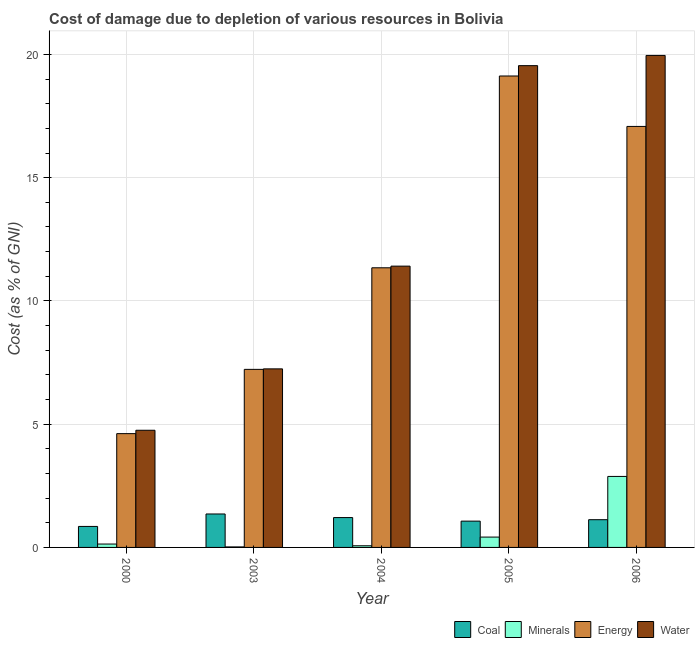How many different coloured bars are there?
Your response must be concise. 4. How many groups of bars are there?
Offer a terse response. 5. Are the number of bars on each tick of the X-axis equal?
Provide a succinct answer. Yes. How many bars are there on the 3rd tick from the left?
Provide a short and direct response. 4. What is the cost of damage due to depletion of minerals in 2004?
Provide a short and direct response. 0.07. Across all years, what is the maximum cost of damage due to depletion of energy?
Your response must be concise. 19.13. Across all years, what is the minimum cost of damage due to depletion of coal?
Ensure brevity in your answer.  0.85. What is the total cost of damage due to depletion of minerals in the graph?
Offer a terse response. 3.52. What is the difference between the cost of damage due to depletion of energy in 2004 and that in 2005?
Keep it short and to the point. -7.78. What is the difference between the cost of damage due to depletion of coal in 2006 and the cost of damage due to depletion of water in 2000?
Make the answer very short. 0.27. What is the average cost of damage due to depletion of water per year?
Offer a very short reply. 12.58. In the year 2005, what is the difference between the cost of damage due to depletion of energy and cost of damage due to depletion of coal?
Your response must be concise. 0. What is the ratio of the cost of damage due to depletion of energy in 2000 to that in 2004?
Your response must be concise. 0.41. What is the difference between the highest and the second highest cost of damage due to depletion of water?
Your answer should be very brief. 0.42. What is the difference between the highest and the lowest cost of damage due to depletion of minerals?
Provide a succinct answer. 2.86. In how many years, is the cost of damage due to depletion of energy greater than the average cost of damage due to depletion of energy taken over all years?
Offer a terse response. 2. What does the 4th bar from the left in 2004 represents?
Give a very brief answer. Water. What does the 4th bar from the right in 2006 represents?
Provide a succinct answer. Coal. Are all the bars in the graph horizontal?
Your response must be concise. No. How many years are there in the graph?
Ensure brevity in your answer.  5. Does the graph contain any zero values?
Offer a terse response. No. How are the legend labels stacked?
Ensure brevity in your answer.  Horizontal. What is the title of the graph?
Offer a very short reply. Cost of damage due to depletion of various resources in Bolivia . What is the label or title of the X-axis?
Your response must be concise. Year. What is the label or title of the Y-axis?
Offer a very short reply. Cost (as % of GNI). What is the Cost (as % of GNI) in Coal in 2000?
Your response must be concise. 0.85. What is the Cost (as % of GNI) in Minerals in 2000?
Ensure brevity in your answer.  0.14. What is the Cost (as % of GNI) of Energy in 2000?
Keep it short and to the point. 4.62. What is the Cost (as % of GNI) of Water in 2000?
Provide a short and direct response. 4.75. What is the Cost (as % of GNI) of Coal in 2003?
Ensure brevity in your answer.  1.36. What is the Cost (as % of GNI) in Minerals in 2003?
Your answer should be very brief. 0.02. What is the Cost (as % of GNI) of Energy in 2003?
Offer a terse response. 7.22. What is the Cost (as % of GNI) of Water in 2003?
Keep it short and to the point. 7.24. What is the Cost (as % of GNI) in Coal in 2004?
Provide a short and direct response. 1.21. What is the Cost (as % of GNI) of Minerals in 2004?
Give a very brief answer. 0.07. What is the Cost (as % of GNI) of Energy in 2004?
Your response must be concise. 11.34. What is the Cost (as % of GNI) of Water in 2004?
Your response must be concise. 11.41. What is the Cost (as % of GNI) of Coal in 2005?
Ensure brevity in your answer.  1.07. What is the Cost (as % of GNI) of Minerals in 2005?
Provide a short and direct response. 0.42. What is the Cost (as % of GNI) in Energy in 2005?
Provide a succinct answer. 19.13. What is the Cost (as % of GNI) in Water in 2005?
Offer a very short reply. 19.54. What is the Cost (as % of GNI) of Coal in 2006?
Your response must be concise. 1.12. What is the Cost (as % of GNI) in Minerals in 2006?
Offer a terse response. 2.88. What is the Cost (as % of GNI) of Energy in 2006?
Your answer should be compact. 17.08. What is the Cost (as % of GNI) in Water in 2006?
Keep it short and to the point. 19.96. Across all years, what is the maximum Cost (as % of GNI) of Coal?
Offer a very short reply. 1.36. Across all years, what is the maximum Cost (as % of GNI) in Minerals?
Your response must be concise. 2.88. Across all years, what is the maximum Cost (as % of GNI) in Energy?
Make the answer very short. 19.13. Across all years, what is the maximum Cost (as % of GNI) of Water?
Provide a short and direct response. 19.96. Across all years, what is the minimum Cost (as % of GNI) of Coal?
Give a very brief answer. 0.85. Across all years, what is the minimum Cost (as % of GNI) in Minerals?
Keep it short and to the point. 0.02. Across all years, what is the minimum Cost (as % of GNI) in Energy?
Your response must be concise. 4.62. Across all years, what is the minimum Cost (as % of GNI) of Water?
Offer a very short reply. 4.75. What is the total Cost (as % of GNI) of Coal in the graph?
Provide a succinct answer. 5.61. What is the total Cost (as % of GNI) in Minerals in the graph?
Make the answer very short. 3.52. What is the total Cost (as % of GNI) in Energy in the graph?
Your answer should be very brief. 59.39. What is the total Cost (as % of GNI) in Water in the graph?
Provide a succinct answer. 62.91. What is the difference between the Cost (as % of GNI) in Coal in 2000 and that in 2003?
Your answer should be compact. -0.5. What is the difference between the Cost (as % of GNI) of Minerals in 2000 and that in 2003?
Your answer should be compact. 0.12. What is the difference between the Cost (as % of GNI) in Energy in 2000 and that in 2003?
Provide a succinct answer. -2.61. What is the difference between the Cost (as % of GNI) in Water in 2000 and that in 2003?
Offer a terse response. -2.49. What is the difference between the Cost (as % of GNI) of Coal in 2000 and that in 2004?
Keep it short and to the point. -0.36. What is the difference between the Cost (as % of GNI) of Minerals in 2000 and that in 2004?
Offer a very short reply. 0.07. What is the difference between the Cost (as % of GNI) in Energy in 2000 and that in 2004?
Make the answer very short. -6.73. What is the difference between the Cost (as % of GNI) of Water in 2000 and that in 2004?
Your response must be concise. -6.66. What is the difference between the Cost (as % of GNI) of Coal in 2000 and that in 2005?
Offer a very short reply. -0.21. What is the difference between the Cost (as % of GNI) of Minerals in 2000 and that in 2005?
Your answer should be compact. -0.28. What is the difference between the Cost (as % of GNI) of Energy in 2000 and that in 2005?
Make the answer very short. -14.51. What is the difference between the Cost (as % of GNI) of Water in 2000 and that in 2005?
Your response must be concise. -14.79. What is the difference between the Cost (as % of GNI) in Coal in 2000 and that in 2006?
Keep it short and to the point. -0.27. What is the difference between the Cost (as % of GNI) of Minerals in 2000 and that in 2006?
Provide a short and direct response. -2.74. What is the difference between the Cost (as % of GNI) in Energy in 2000 and that in 2006?
Give a very brief answer. -12.46. What is the difference between the Cost (as % of GNI) in Water in 2000 and that in 2006?
Provide a succinct answer. -15.21. What is the difference between the Cost (as % of GNI) of Coal in 2003 and that in 2004?
Your answer should be compact. 0.15. What is the difference between the Cost (as % of GNI) in Minerals in 2003 and that in 2004?
Give a very brief answer. -0.05. What is the difference between the Cost (as % of GNI) of Energy in 2003 and that in 2004?
Your response must be concise. -4.12. What is the difference between the Cost (as % of GNI) of Water in 2003 and that in 2004?
Ensure brevity in your answer.  -4.17. What is the difference between the Cost (as % of GNI) in Coal in 2003 and that in 2005?
Your response must be concise. 0.29. What is the difference between the Cost (as % of GNI) of Minerals in 2003 and that in 2005?
Your answer should be compact. -0.4. What is the difference between the Cost (as % of GNI) of Energy in 2003 and that in 2005?
Provide a short and direct response. -11.9. What is the difference between the Cost (as % of GNI) of Water in 2003 and that in 2005?
Your answer should be compact. -12.3. What is the difference between the Cost (as % of GNI) in Coal in 2003 and that in 2006?
Offer a very short reply. 0.23. What is the difference between the Cost (as % of GNI) of Minerals in 2003 and that in 2006?
Make the answer very short. -2.86. What is the difference between the Cost (as % of GNI) of Energy in 2003 and that in 2006?
Provide a succinct answer. -9.86. What is the difference between the Cost (as % of GNI) of Water in 2003 and that in 2006?
Provide a short and direct response. -12.72. What is the difference between the Cost (as % of GNI) of Coal in 2004 and that in 2005?
Provide a short and direct response. 0.14. What is the difference between the Cost (as % of GNI) of Minerals in 2004 and that in 2005?
Offer a very short reply. -0.35. What is the difference between the Cost (as % of GNI) of Energy in 2004 and that in 2005?
Keep it short and to the point. -7.78. What is the difference between the Cost (as % of GNI) in Water in 2004 and that in 2005?
Offer a very short reply. -8.13. What is the difference between the Cost (as % of GNI) of Coal in 2004 and that in 2006?
Your response must be concise. 0.09. What is the difference between the Cost (as % of GNI) in Minerals in 2004 and that in 2006?
Make the answer very short. -2.81. What is the difference between the Cost (as % of GNI) in Energy in 2004 and that in 2006?
Your response must be concise. -5.73. What is the difference between the Cost (as % of GNI) of Water in 2004 and that in 2006?
Your response must be concise. -8.55. What is the difference between the Cost (as % of GNI) of Coal in 2005 and that in 2006?
Provide a succinct answer. -0.06. What is the difference between the Cost (as % of GNI) in Minerals in 2005 and that in 2006?
Provide a succinct answer. -2.46. What is the difference between the Cost (as % of GNI) of Energy in 2005 and that in 2006?
Offer a terse response. 2.05. What is the difference between the Cost (as % of GNI) of Water in 2005 and that in 2006?
Keep it short and to the point. -0.41. What is the difference between the Cost (as % of GNI) in Coal in 2000 and the Cost (as % of GNI) in Minerals in 2003?
Ensure brevity in your answer.  0.83. What is the difference between the Cost (as % of GNI) in Coal in 2000 and the Cost (as % of GNI) in Energy in 2003?
Provide a short and direct response. -6.37. What is the difference between the Cost (as % of GNI) in Coal in 2000 and the Cost (as % of GNI) in Water in 2003?
Your answer should be compact. -6.39. What is the difference between the Cost (as % of GNI) in Minerals in 2000 and the Cost (as % of GNI) in Energy in 2003?
Offer a very short reply. -7.09. What is the difference between the Cost (as % of GNI) of Minerals in 2000 and the Cost (as % of GNI) of Water in 2003?
Provide a succinct answer. -7.11. What is the difference between the Cost (as % of GNI) of Energy in 2000 and the Cost (as % of GNI) of Water in 2003?
Provide a succinct answer. -2.63. What is the difference between the Cost (as % of GNI) of Coal in 2000 and the Cost (as % of GNI) of Minerals in 2004?
Your response must be concise. 0.78. What is the difference between the Cost (as % of GNI) in Coal in 2000 and the Cost (as % of GNI) in Energy in 2004?
Your response must be concise. -10.49. What is the difference between the Cost (as % of GNI) of Coal in 2000 and the Cost (as % of GNI) of Water in 2004?
Keep it short and to the point. -10.56. What is the difference between the Cost (as % of GNI) in Minerals in 2000 and the Cost (as % of GNI) in Energy in 2004?
Keep it short and to the point. -11.21. What is the difference between the Cost (as % of GNI) in Minerals in 2000 and the Cost (as % of GNI) in Water in 2004?
Keep it short and to the point. -11.27. What is the difference between the Cost (as % of GNI) in Energy in 2000 and the Cost (as % of GNI) in Water in 2004?
Your answer should be very brief. -6.8. What is the difference between the Cost (as % of GNI) of Coal in 2000 and the Cost (as % of GNI) of Minerals in 2005?
Provide a succinct answer. 0.43. What is the difference between the Cost (as % of GNI) of Coal in 2000 and the Cost (as % of GNI) of Energy in 2005?
Offer a very short reply. -18.27. What is the difference between the Cost (as % of GNI) of Coal in 2000 and the Cost (as % of GNI) of Water in 2005?
Make the answer very short. -18.69. What is the difference between the Cost (as % of GNI) of Minerals in 2000 and the Cost (as % of GNI) of Energy in 2005?
Your answer should be very brief. -18.99. What is the difference between the Cost (as % of GNI) in Minerals in 2000 and the Cost (as % of GNI) in Water in 2005?
Your answer should be compact. -19.41. What is the difference between the Cost (as % of GNI) in Energy in 2000 and the Cost (as % of GNI) in Water in 2005?
Your answer should be very brief. -14.93. What is the difference between the Cost (as % of GNI) of Coal in 2000 and the Cost (as % of GNI) of Minerals in 2006?
Make the answer very short. -2.03. What is the difference between the Cost (as % of GNI) of Coal in 2000 and the Cost (as % of GNI) of Energy in 2006?
Offer a terse response. -16.23. What is the difference between the Cost (as % of GNI) in Coal in 2000 and the Cost (as % of GNI) in Water in 2006?
Offer a very short reply. -19.11. What is the difference between the Cost (as % of GNI) of Minerals in 2000 and the Cost (as % of GNI) of Energy in 2006?
Your answer should be very brief. -16.94. What is the difference between the Cost (as % of GNI) of Minerals in 2000 and the Cost (as % of GNI) of Water in 2006?
Ensure brevity in your answer.  -19.82. What is the difference between the Cost (as % of GNI) of Energy in 2000 and the Cost (as % of GNI) of Water in 2006?
Make the answer very short. -15.34. What is the difference between the Cost (as % of GNI) in Coal in 2003 and the Cost (as % of GNI) in Minerals in 2004?
Your response must be concise. 1.29. What is the difference between the Cost (as % of GNI) of Coal in 2003 and the Cost (as % of GNI) of Energy in 2004?
Your answer should be compact. -9.99. What is the difference between the Cost (as % of GNI) in Coal in 2003 and the Cost (as % of GNI) in Water in 2004?
Give a very brief answer. -10.05. What is the difference between the Cost (as % of GNI) in Minerals in 2003 and the Cost (as % of GNI) in Energy in 2004?
Offer a terse response. -11.32. What is the difference between the Cost (as % of GNI) of Minerals in 2003 and the Cost (as % of GNI) of Water in 2004?
Ensure brevity in your answer.  -11.39. What is the difference between the Cost (as % of GNI) of Energy in 2003 and the Cost (as % of GNI) of Water in 2004?
Provide a succinct answer. -4.19. What is the difference between the Cost (as % of GNI) in Coal in 2003 and the Cost (as % of GNI) in Minerals in 2005?
Provide a short and direct response. 0.94. What is the difference between the Cost (as % of GNI) of Coal in 2003 and the Cost (as % of GNI) of Energy in 2005?
Provide a short and direct response. -17.77. What is the difference between the Cost (as % of GNI) of Coal in 2003 and the Cost (as % of GNI) of Water in 2005?
Offer a terse response. -18.19. What is the difference between the Cost (as % of GNI) of Minerals in 2003 and the Cost (as % of GNI) of Energy in 2005?
Offer a very short reply. -19.1. What is the difference between the Cost (as % of GNI) of Minerals in 2003 and the Cost (as % of GNI) of Water in 2005?
Offer a very short reply. -19.52. What is the difference between the Cost (as % of GNI) in Energy in 2003 and the Cost (as % of GNI) in Water in 2005?
Ensure brevity in your answer.  -12.32. What is the difference between the Cost (as % of GNI) of Coal in 2003 and the Cost (as % of GNI) of Minerals in 2006?
Your response must be concise. -1.52. What is the difference between the Cost (as % of GNI) in Coal in 2003 and the Cost (as % of GNI) in Energy in 2006?
Your answer should be compact. -15.72. What is the difference between the Cost (as % of GNI) in Coal in 2003 and the Cost (as % of GNI) in Water in 2006?
Offer a terse response. -18.6. What is the difference between the Cost (as % of GNI) in Minerals in 2003 and the Cost (as % of GNI) in Energy in 2006?
Offer a very short reply. -17.06. What is the difference between the Cost (as % of GNI) of Minerals in 2003 and the Cost (as % of GNI) of Water in 2006?
Your answer should be compact. -19.94. What is the difference between the Cost (as % of GNI) in Energy in 2003 and the Cost (as % of GNI) in Water in 2006?
Keep it short and to the point. -12.74. What is the difference between the Cost (as % of GNI) in Coal in 2004 and the Cost (as % of GNI) in Minerals in 2005?
Give a very brief answer. 0.79. What is the difference between the Cost (as % of GNI) in Coal in 2004 and the Cost (as % of GNI) in Energy in 2005?
Provide a succinct answer. -17.91. What is the difference between the Cost (as % of GNI) in Coal in 2004 and the Cost (as % of GNI) in Water in 2005?
Provide a short and direct response. -18.33. What is the difference between the Cost (as % of GNI) in Minerals in 2004 and the Cost (as % of GNI) in Energy in 2005?
Your answer should be very brief. -19.06. What is the difference between the Cost (as % of GNI) of Minerals in 2004 and the Cost (as % of GNI) of Water in 2005?
Give a very brief answer. -19.48. What is the difference between the Cost (as % of GNI) in Energy in 2004 and the Cost (as % of GNI) in Water in 2005?
Provide a succinct answer. -8.2. What is the difference between the Cost (as % of GNI) in Coal in 2004 and the Cost (as % of GNI) in Minerals in 2006?
Your answer should be compact. -1.67. What is the difference between the Cost (as % of GNI) of Coal in 2004 and the Cost (as % of GNI) of Energy in 2006?
Provide a short and direct response. -15.87. What is the difference between the Cost (as % of GNI) in Coal in 2004 and the Cost (as % of GNI) in Water in 2006?
Make the answer very short. -18.75. What is the difference between the Cost (as % of GNI) of Minerals in 2004 and the Cost (as % of GNI) of Energy in 2006?
Provide a short and direct response. -17.01. What is the difference between the Cost (as % of GNI) in Minerals in 2004 and the Cost (as % of GNI) in Water in 2006?
Your answer should be compact. -19.89. What is the difference between the Cost (as % of GNI) of Energy in 2004 and the Cost (as % of GNI) of Water in 2006?
Your answer should be compact. -8.62. What is the difference between the Cost (as % of GNI) of Coal in 2005 and the Cost (as % of GNI) of Minerals in 2006?
Give a very brief answer. -1.81. What is the difference between the Cost (as % of GNI) in Coal in 2005 and the Cost (as % of GNI) in Energy in 2006?
Provide a succinct answer. -16.01. What is the difference between the Cost (as % of GNI) in Coal in 2005 and the Cost (as % of GNI) in Water in 2006?
Keep it short and to the point. -18.89. What is the difference between the Cost (as % of GNI) of Minerals in 2005 and the Cost (as % of GNI) of Energy in 2006?
Provide a short and direct response. -16.66. What is the difference between the Cost (as % of GNI) in Minerals in 2005 and the Cost (as % of GNI) in Water in 2006?
Give a very brief answer. -19.54. What is the difference between the Cost (as % of GNI) of Energy in 2005 and the Cost (as % of GNI) of Water in 2006?
Offer a very short reply. -0.83. What is the average Cost (as % of GNI) of Coal per year?
Offer a very short reply. 1.12. What is the average Cost (as % of GNI) of Minerals per year?
Ensure brevity in your answer.  0.7. What is the average Cost (as % of GNI) of Energy per year?
Your answer should be very brief. 11.88. What is the average Cost (as % of GNI) of Water per year?
Your answer should be compact. 12.58. In the year 2000, what is the difference between the Cost (as % of GNI) of Coal and Cost (as % of GNI) of Minerals?
Give a very brief answer. 0.71. In the year 2000, what is the difference between the Cost (as % of GNI) of Coal and Cost (as % of GNI) of Energy?
Keep it short and to the point. -3.76. In the year 2000, what is the difference between the Cost (as % of GNI) of Coal and Cost (as % of GNI) of Water?
Give a very brief answer. -3.9. In the year 2000, what is the difference between the Cost (as % of GNI) of Minerals and Cost (as % of GNI) of Energy?
Provide a succinct answer. -4.48. In the year 2000, what is the difference between the Cost (as % of GNI) of Minerals and Cost (as % of GNI) of Water?
Your answer should be very brief. -4.62. In the year 2000, what is the difference between the Cost (as % of GNI) in Energy and Cost (as % of GNI) in Water?
Make the answer very short. -0.14. In the year 2003, what is the difference between the Cost (as % of GNI) of Coal and Cost (as % of GNI) of Minerals?
Make the answer very short. 1.34. In the year 2003, what is the difference between the Cost (as % of GNI) in Coal and Cost (as % of GNI) in Energy?
Make the answer very short. -5.87. In the year 2003, what is the difference between the Cost (as % of GNI) in Coal and Cost (as % of GNI) in Water?
Provide a short and direct response. -5.89. In the year 2003, what is the difference between the Cost (as % of GNI) of Minerals and Cost (as % of GNI) of Energy?
Your response must be concise. -7.2. In the year 2003, what is the difference between the Cost (as % of GNI) in Minerals and Cost (as % of GNI) in Water?
Your response must be concise. -7.22. In the year 2003, what is the difference between the Cost (as % of GNI) of Energy and Cost (as % of GNI) of Water?
Ensure brevity in your answer.  -0.02. In the year 2004, what is the difference between the Cost (as % of GNI) in Coal and Cost (as % of GNI) in Minerals?
Provide a succinct answer. 1.14. In the year 2004, what is the difference between the Cost (as % of GNI) in Coal and Cost (as % of GNI) in Energy?
Provide a short and direct response. -10.13. In the year 2004, what is the difference between the Cost (as % of GNI) of Coal and Cost (as % of GNI) of Water?
Provide a succinct answer. -10.2. In the year 2004, what is the difference between the Cost (as % of GNI) of Minerals and Cost (as % of GNI) of Energy?
Ensure brevity in your answer.  -11.28. In the year 2004, what is the difference between the Cost (as % of GNI) of Minerals and Cost (as % of GNI) of Water?
Your answer should be very brief. -11.34. In the year 2004, what is the difference between the Cost (as % of GNI) of Energy and Cost (as % of GNI) of Water?
Offer a very short reply. -0.07. In the year 2005, what is the difference between the Cost (as % of GNI) of Coal and Cost (as % of GNI) of Minerals?
Offer a very short reply. 0.65. In the year 2005, what is the difference between the Cost (as % of GNI) of Coal and Cost (as % of GNI) of Energy?
Your response must be concise. -18.06. In the year 2005, what is the difference between the Cost (as % of GNI) in Coal and Cost (as % of GNI) in Water?
Give a very brief answer. -18.48. In the year 2005, what is the difference between the Cost (as % of GNI) of Minerals and Cost (as % of GNI) of Energy?
Offer a very short reply. -18.71. In the year 2005, what is the difference between the Cost (as % of GNI) in Minerals and Cost (as % of GNI) in Water?
Offer a terse response. -19.13. In the year 2005, what is the difference between the Cost (as % of GNI) of Energy and Cost (as % of GNI) of Water?
Provide a succinct answer. -0.42. In the year 2006, what is the difference between the Cost (as % of GNI) in Coal and Cost (as % of GNI) in Minerals?
Your answer should be very brief. -1.76. In the year 2006, what is the difference between the Cost (as % of GNI) of Coal and Cost (as % of GNI) of Energy?
Offer a very short reply. -15.95. In the year 2006, what is the difference between the Cost (as % of GNI) of Coal and Cost (as % of GNI) of Water?
Provide a short and direct response. -18.83. In the year 2006, what is the difference between the Cost (as % of GNI) in Minerals and Cost (as % of GNI) in Energy?
Offer a terse response. -14.2. In the year 2006, what is the difference between the Cost (as % of GNI) in Minerals and Cost (as % of GNI) in Water?
Give a very brief answer. -17.08. In the year 2006, what is the difference between the Cost (as % of GNI) of Energy and Cost (as % of GNI) of Water?
Keep it short and to the point. -2.88. What is the ratio of the Cost (as % of GNI) of Coal in 2000 to that in 2003?
Ensure brevity in your answer.  0.63. What is the ratio of the Cost (as % of GNI) in Minerals in 2000 to that in 2003?
Your response must be concise. 6.68. What is the ratio of the Cost (as % of GNI) of Energy in 2000 to that in 2003?
Offer a very short reply. 0.64. What is the ratio of the Cost (as % of GNI) of Water in 2000 to that in 2003?
Make the answer very short. 0.66. What is the ratio of the Cost (as % of GNI) of Coal in 2000 to that in 2004?
Give a very brief answer. 0.7. What is the ratio of the Cost (as % of GNI) of Minerals in 2000 to that in 2004?
Keep it short and to the point. 2.04. What is the ratio of the Cost (as % of GNI) of Energy in 2000 to that in 2004?
Your answer should be compact. 0.41. What is the ratio of the Cost (as % of GNI) of Water in 2000 to that in 2004?
Your answer should be very brief. 0.42. What is the ratio of the Cost (as % of GNI) in Coal in 2000 to that in 2005?
Keep it short and to the point. 0.8. What is the ratio of the Cost (as % of GNI) in Minerals in 2000 to that in 2005?
Give a very brief answer. 0.33. What is the ratio of the Cost (as % of GNI) of Energy in 2000 to that in 2005?
Your answer should be very brief. 0.24. What is the ratio of the Cost (as % of GNI) in Water in 2000 to that in 2005?
Provide a succinct answer. 0.24. What is the ratio of the Cost (as % of GNI) in Coal in 2000 to that in 2006?
Provide a short and direct response. 0.76. What is the ratio of the Cost (as % of GNI) of Minerals in 2000 to that in 2006?
Your answer should be very brief. 0.05. What is the ratio of the Cost (as % of GNI) of Energy in 2000 to that in 2006?
Provide a succinct answer. 0.27. What is the ratio of the Cost (as % of GNI) of Water in 2000 to that in 2006?
Provide a succinct answer. 0.24. What is the ratio of the Cost (as % of GNI) of Coal in 2003 to that in 2004?
Give a very brief answer. 1.12. What is the ratio of the Cost (as % of GNI) in Minerals in 2003 to that in 2004?
Ensure brevity in your answer.  0.31. What is the ratio of the Cost (as % of GNI) in Energy in 2003 to that in 2004?
Offer a very short reply. 0.64. What is the ratio of the Cost (as % of GNI) of Water in 2003 to that in 2004?
Your answer should be very brief. 0.63. What is the ratio of the Cost (as % of GNI) in Coal in 2003 to that in 2005?
Provide a succinct answer. 1.27. What is the ratio of the Cost (as % of GNI) in Minerals in 2003 to that in 2005?
Provide a succinct answer. 0.05. What is the ratio of the Cost (as % of GNI) in Energy in 2003 to that in 2005?
Ensure brevity in your answer.  0.38. What is the ratio of the Cost (as % of GNI) in Water in 2003 to that in 2005?
Provide a short and direct response. 0.37. What is the ratio of the Cost (as % of GNI) of Coal in 2003 to that in 2006?
Your answer should be compact. 1.21. What is the ratio of the Cost (as % of GNI) in Minerals in 2003 to that in 2006?
Offer a terse response. 0.01. What is the ratio of the Cost (as % of GNI) in Energy in 2003 to that in 2006?
Offer a very short reply. 0.42. What is the ratio of the Cost (as % of GNI) in Water in 2003 to that in 2006?
Provide a succinct answer. 0.36. What is the ratio of the Cost (as % of GNI) in Coal in 2004 to that in 2005?
Your answer should be very brief. 1.14. What is the ratio of the Cost (as % of GNI) in Minerals in 2004 to that in 2005?
Give a very brief answer. 0.16. What is the ratio of the Cost (as % of GNI) of Energy in 2004 to that in 2005?
Ensure brevity in your answer.  0.59. What is the ratio of the Cost (as % of GNI) in Water in 2004 to that in 2005?
Your answer should be compact. 0.58. What is the ratio of the Cost (as % of GNI) in Coal in 2004 to that in 2006?
Keep it short and to the point. 1.08. What is the ratio of the Cost (as % of GNI) of Minerals in 2004 to that in 2006?
Give a very brief answer. 0.02. What is the ratio of the Cost (as % of GNI) in Energy in 2004 to that in 2006?
Give a very brief answer. 0.66. What is the ratio of the Cost (as % of GNI) of Water in 2004 to that in 2006?
Keep it short and to the point. 0.57. What is the ratio of the Cost (as % of GNI) in Coal in 2005 to that in 2006?
Keep it short and to the point. 0.95. What is the ratio of the Cost (as % of GNI) in Minerals in 2005 to that in 2006?
Your answer should be compact. 0.15. What is the ratio of the Cost (as % of GNI) in Energy in 2005 to that in 2006?
Offer a terse response. 1.12. What is the ratio of the Cost (as % of GNI) in Water in 2005 to that in 2006?
Offer a terse response. 0.98. What is the difference between the highest and the second highest Cost (as % of GNI) of Coal?
Ensure brevity in your answer.  0.15. What is the difference between the highest and the second highest Cost (as % of GNI) in Minerals?
Provide a short and direct response. 2.46. What is the difference between the highest and the second highest Cost (as % of GNI) of Energy?
Provide a succinct answer. 2.05. What is the difference between the highest and the second highest Cost (as % of GNI) of Water?
Your response must be concise. 0.41. What is the difference between the highest and the lowest Cost (as % of GNI) in Coal?
Your answer should be compact. 0.5. What is the difference between the highest and the lowest Cost (as % of GNI) in Minerals?
Offer a terse response. 2.86. What is the difference between the highest and the lowest Cost (as % of GNI) in Energy?
Your answer should be compact. 14.51. What is the difference between the highest and the lowest Cost (as % of GNI) in Water?
Make the answer very short. 15.21. 